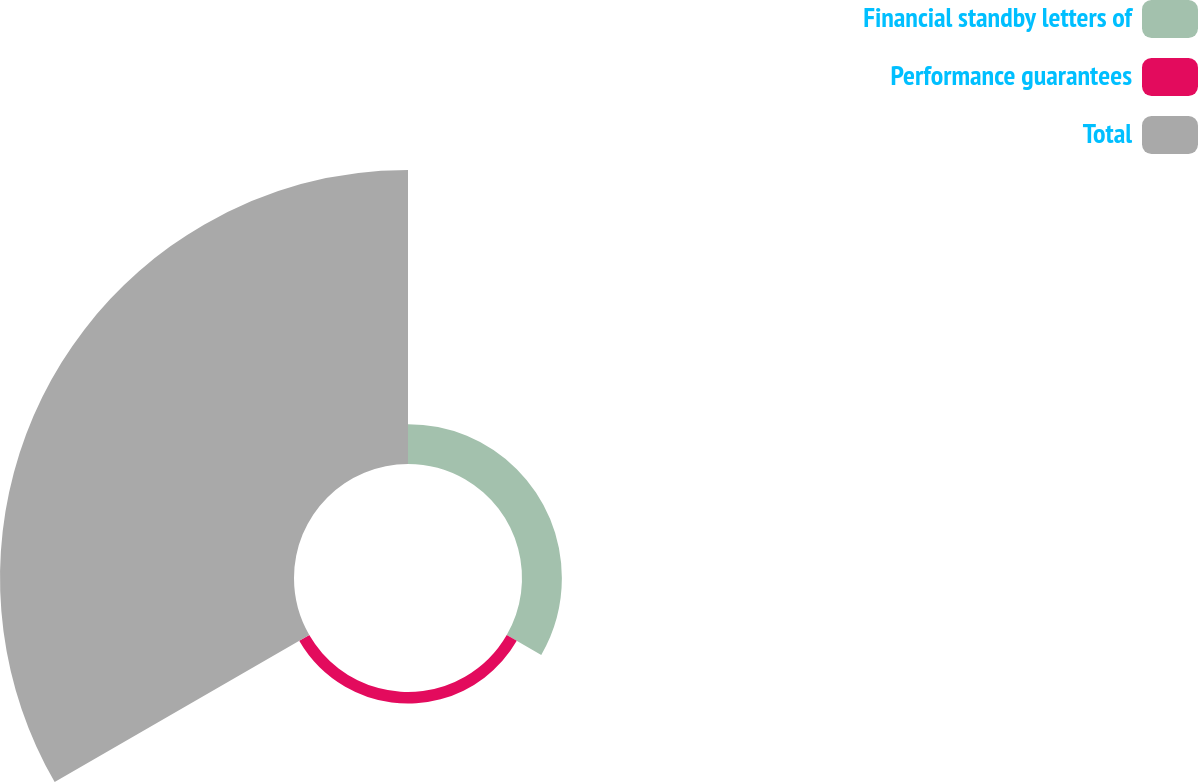<chart> <loc_0><loc_0><loc_500><loc_500><pie_chart><fcel>Financial standby letters of<fcel>Performance guarantees<fcel>Total<nl><fcel>11.54%<fcel>3.36%<fcel>85.1%<nl></chart> 